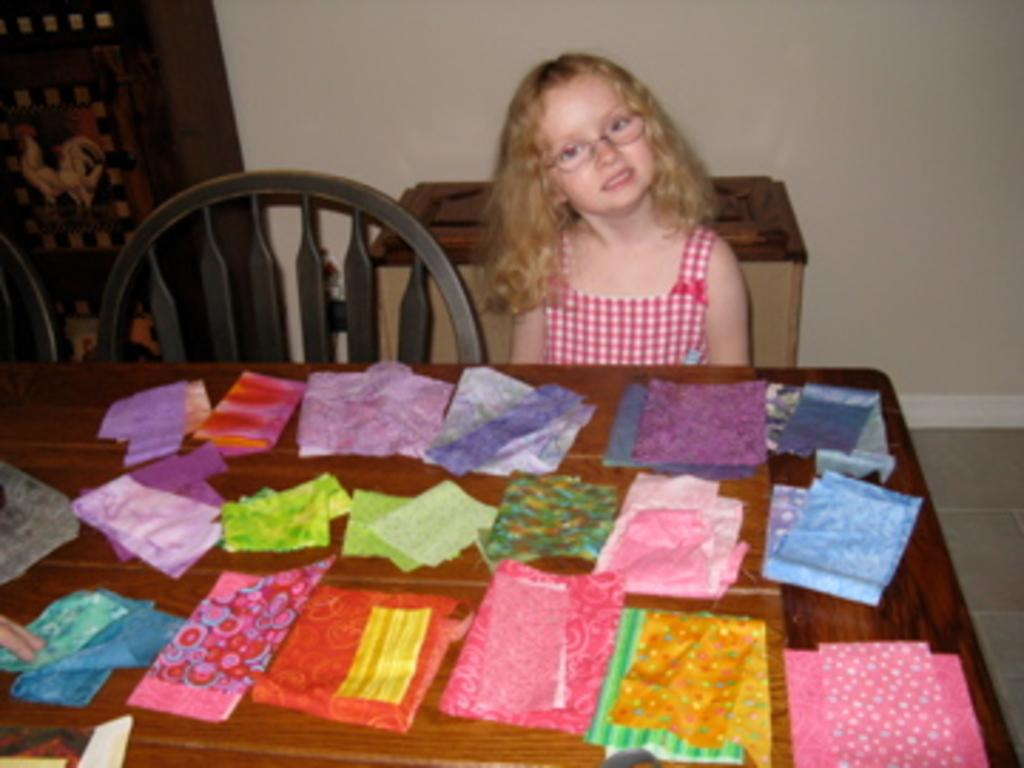Who is the main subject in the image? There is a girl in the image. What piece of furniture is visible in the image? There is a chair in the image. What other piece of furniture is present in the image? There is a table in the image. What type of objects are made of cloth in the image? Cloth pieces are present in the image. What type of headwear is the girl wearing in the image? There is no headwear visible on the girl in the image. Can you describe the whip that the girl is holding in the image? There is no whip present in the image. 